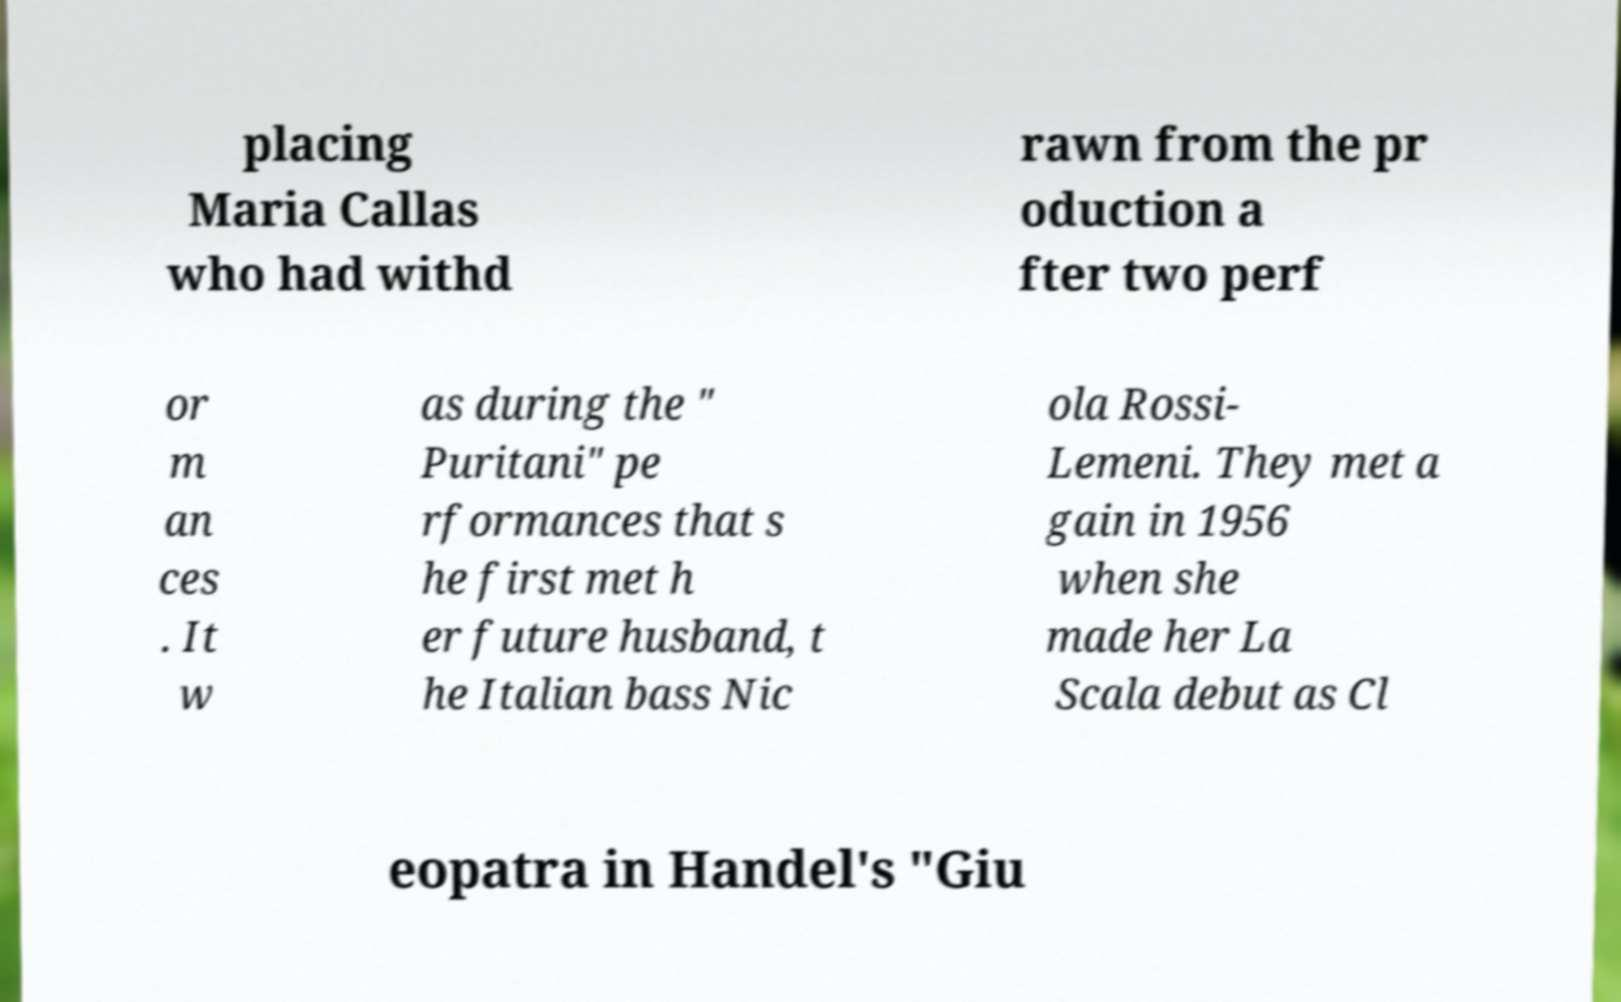Can you accurately transcribe the text from the provided image for me? placing Maria Callas who had withd rawn from the pr oduction a fter two perf or m an ces . It w as during the " Puritani" pe rformances that s he first met h er future husband, t he Italian bass Nic ola Rossi- Lemeni. They met a gain in 1956 when she made her La Scala debut as Cl eopatra in Handel's "Giu 